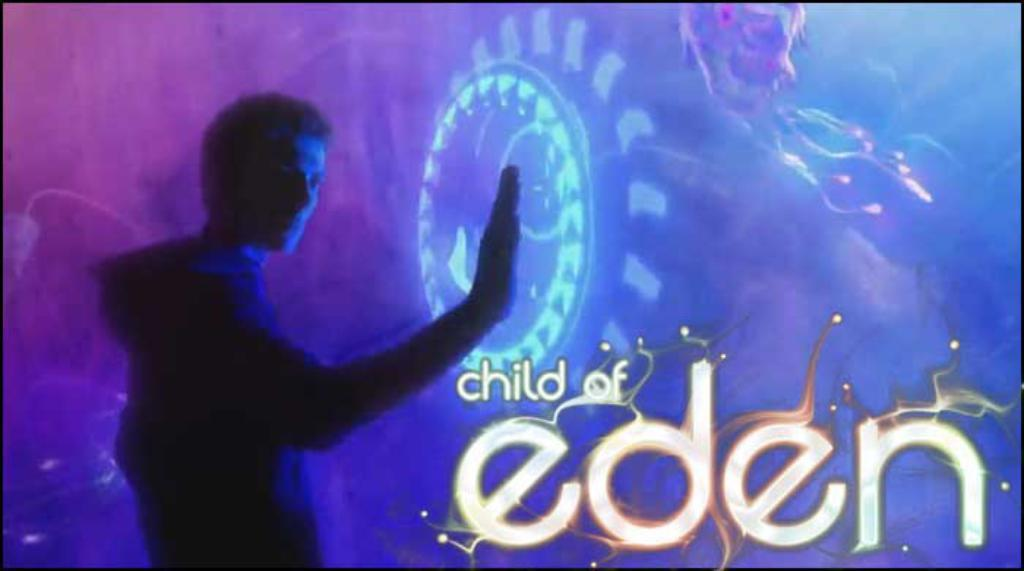What is the main subject of the image? The main subject of the image is a man standing. What is in front of the man? There is a screen in front of the man. What type of comb is the creature using to groom itself in the image? There is no creature or comb present in the image; it features a man standing with a screen in front of him. 